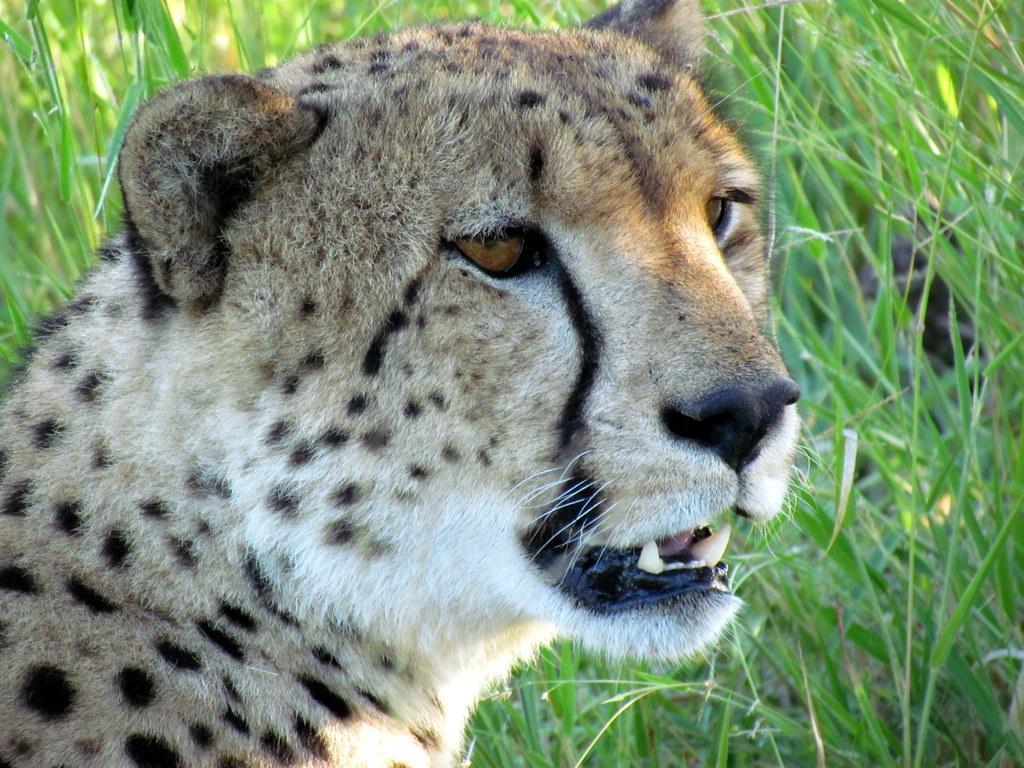How would you summarize this image in a sentence or two? In this image there is a cheetah. In the background, I can see the grass. 